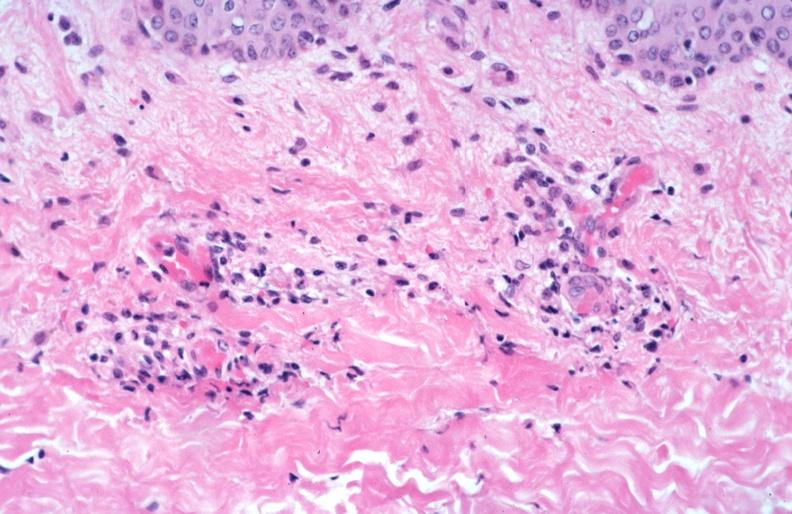what does this image show?
Answer the question using a single word or phrase. Skin 